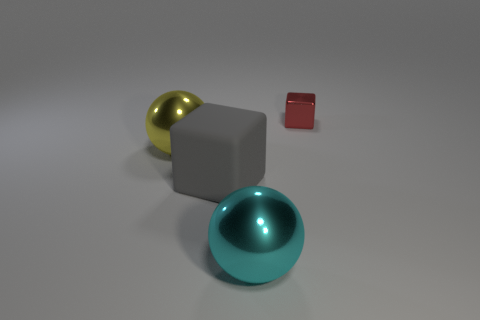Are there any other things that are the same size as the red shiny thing?
Ensure brevity in your answer.  No. Is the number of shiny objects less than the number of objects?
Your answer should be compact. Yes. There is a thing that is both in front of the large yellow sphere and behind the large cyan metal object; what shape is it?
Provide a succinct answer. Cube. What number of big red cubes are there?
Your answer should be compact. 0. What is the material of the cube in front of the ball that is behind the big block that is to the right of the big yellow object?
Provide a succinct answer. Rubber. How many big matte objects are on the right side of the block that is in front of the red thing?
Your response must be concise. 0. There is another thing that is the same shape as the cyan thing; what color is it?
Make the answer very short. Yellow. Is the big yellow ball made of the same material as the large cyan ball?
Offer a terse response. Yes. How many blocks are big cyan objects or big gray things?
Ensure brevity in your answer.  1. What size is the shiny object behind the big ball left of the cube in front of the red block?
Offer a very short reply. Small. 